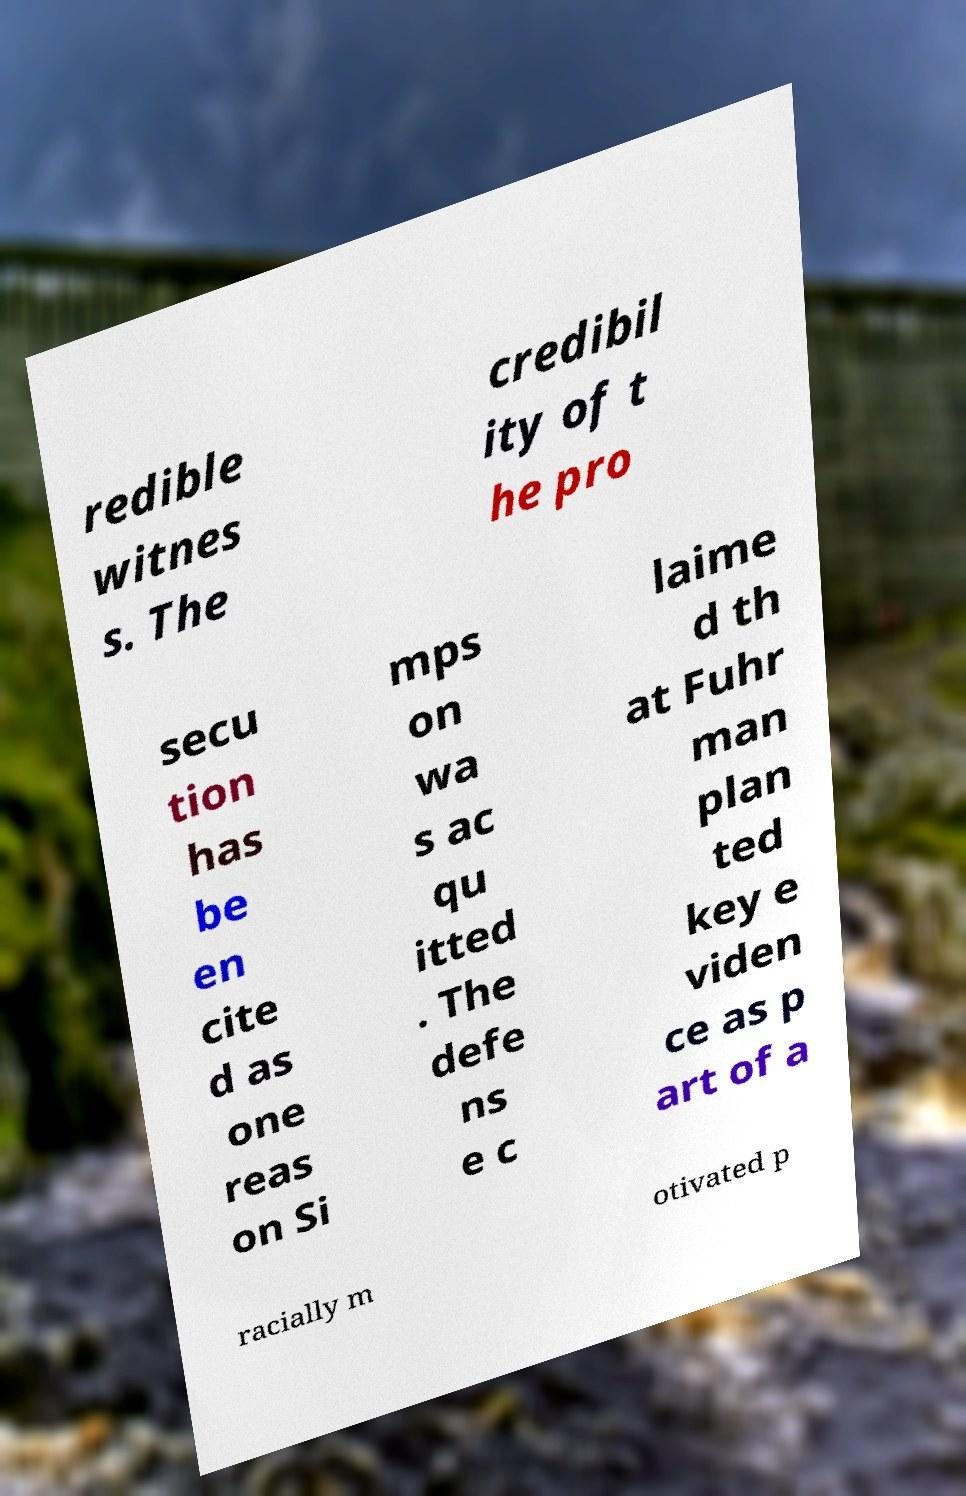Please identify and transcribe the text found in this image. redible witnes s. The credibil ity of t he pro secu tion has be en cite d as one reas on Si mps on wa s ac qu itted . The defe ns e c laime d th at Fuhr man plan ted key e viden ce as p art of a racially m otivated p 